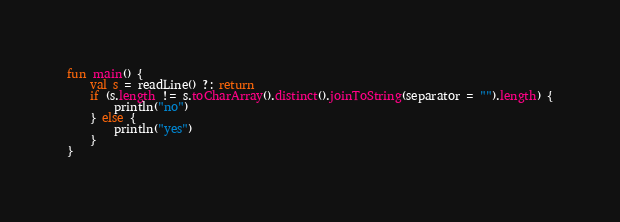<code> <loc_0><loc_0><loc_500><loc_500><_Kotlin_>fun main() {
    val s = readLine() ?: return
    if (s.length != s.toCharArray().distinct().joinToString(separator = "").length) {
        println("no")
    } else {
        println("yes")
    }
}</code> 